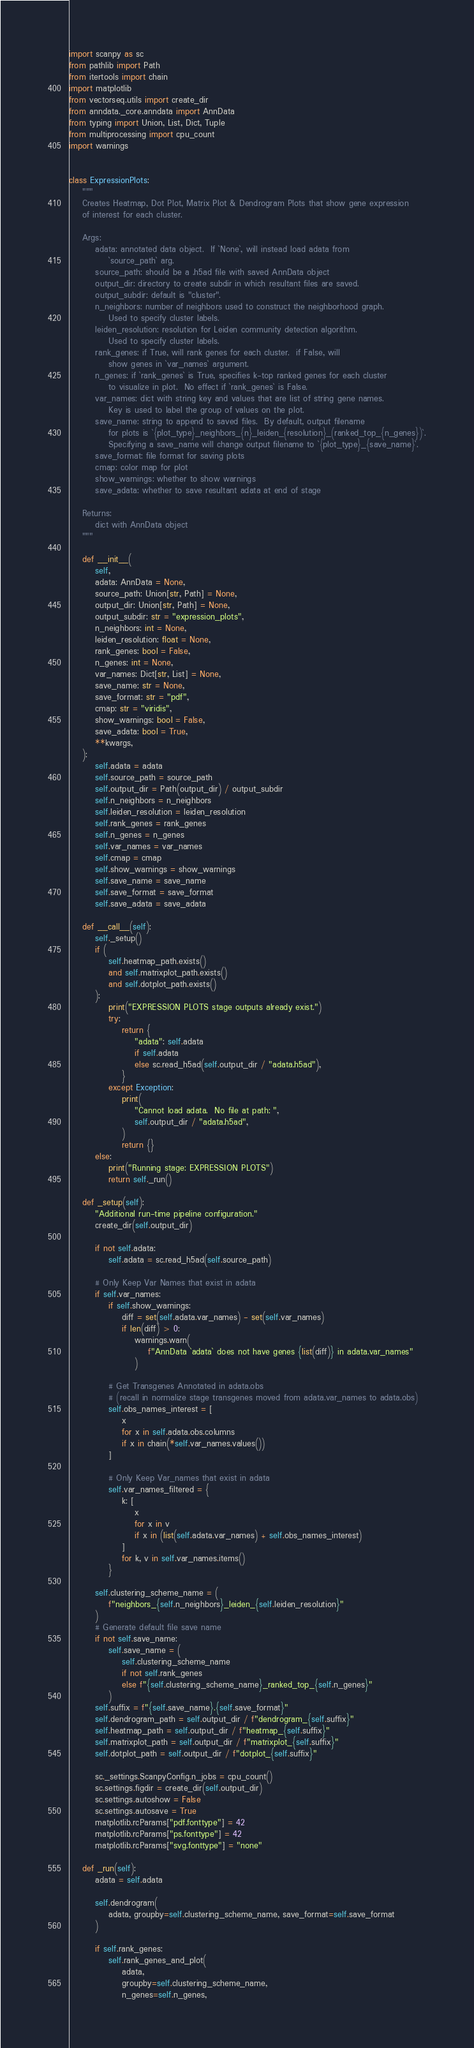Convert code to text. <code><loc_0><loc_0><loc_500><loc_500><_Python_>import scanpy as sc
from pathlib import Path
from itertools import chain
import matplotlib
from vectorseq.utils import create_dir
from anndata._core.anndata import AnnData
from typing import Union, List, Dict, Tuple
from multiprocessing import cpu_count
import warnings


class ExpressionPlots:
    """
    Creates Heatmap, Dot Plot, Matrix Plot & Dendrogram Plots that show gene expression
    of interest for each cluster.

    Args:
        adata: annotated data object.  If `None`, will instead load adata from
            `source_path` arg.
        source_path: should be a .h5ad file with saved AnnData object
        output_dir: directory to create subdir in which resultant files are saved.
        output_subdir: default is "cluster".
        n_neighbors: number of neighbors used to construct the neighborhood graph.
            Used to specify cluster labels.
        leiden_resolution: resolution for Leiden community detection algorithm.
            Used to specify cluster labels.
        rank_genes: if True, will rank genes for each cluster.  if False, will
            show genes in `var_names` argument.
        n_genes: if `rank_genes` is True, specifies k-top ranked genes for each cluster
            to visualize in plot.  No effect if `rank_genes` is False.
        var_names: dict with string key and values that are list of string gene names.
            Key is used to label the group of values on the plot.
        save_name: string to append to saved files.  By default, output filename
            for plots is `{plot_type}_neighbors_{n}_leiden_{resolution}_(ranked_top_{n_genes})`.
            Specifying a save_name will change output filename to `{plot_type}_{save_name}`.
        save_format: file format for saving plots
        cmap: color map for plot
        show_warnings: whether to show warnings
        save_adata: whether to save resultant adata at end of stage

    Returns:
        dict with AnnData object
    """

    def __init__(
        self,
        adata: AnnData = None,
        source_path: Union[str, Path] = None,
        output_dir: Union[str, Path] = None,
        output_subdir: str = "expression_plots",
        n_neighbors: int = None,
        leiden_resolution: float = None,
        rank_genes: bool = False,
        n_genes: int = None,
        var_names: Dict[str, List] = None,
        save_name: str = None,
        save_format: str = "pdf",
        cmap: str = "viridis",
        show_warnings: bool = False,
        save_adata: bool = True,
        **kwargs,
    ):
        self.adata = adata
        self.source_path = source_path
        self.output_dir = Path(output_dir) / output_subdir
        self.n_neighbors = n_neighbors
        self.leiden_resolution = leiden_resolution
        self.rank_genes = rank_genes
        self.n_genes = n_genes
        self.var_names = var_names
        self.cmap = cmap
        self.show_warnings = show_warnings
        self.save_name = save_name
        self.save_format = save_format
        self.save_adata = save_adata

    def __call__(self):
        self._setup()
        if (
            self.heatmap_path.exists()
            and self.matrixplot_path.exists()
            and self.dotplot_path.exists()
        ):
            print("EXPRESSION PLOTS stage outputs already exist.")
            try:
                return {
                    "adata": self.adata
                    if self.adata
                    else sc.read_h5ad(self.output_dir / "adata.h5ad"),
                }
            except Exception:
                print(
                    "Cannot load adata.  No file at path: ",
                    self.output_dir / "adata.h5ad",
                )
                return {}
        else:
            print("Running stage: EXPRESSION PLOTS")
            return self._run()

    def _setup(self):
        "Additional run-time pipeline configuration."
        create_dir(self.output_dir)

        if not self.adata:
            self.adata = sc.read_h5ad(self.source_path)

        # Only Keep Var Names that exist in adata
        if self.var_names:
            if self.show_warnings:
                diff = set(self.adata.var_names) - set(self.var_names)
                if len(diff) > 0:
                    warnings.warn(
                        f"AnnData `adata` does not have genes {list(diff)} in adata.var_names"
                    )

            # Get Transgenes Annotated in adata.obs
            # (recall in normalize stage transgenes moved from adata.var_names to adata.obs)
            self.obs_names_interest = [
                x
                for x in self.adata.obs.columns
                if x in chain(*self.var_names.values())
            ]

            # Only Keep Var_names that exist in adata
            self.var_names_filtered = {
                k: [
                    x
                    for x in v
                    if x in (list(self.adata.var_names) + self.obs_names_interest)
                ]
                for k, v in self.var_names.items()
            }

        self.clustering_scheme_name = (
            f"neighbors_{self.n_neighbors}_leiden_{self.leiden_resolution}"
        )
        # Generate default file save name
        if not self.save_name:
            self.save_name = (
                self.clustering_scheme_name
                if not self.rank_genes
                else f"{self.clustering_scheme_name}_ranked_top_{self.n_genes}"
            )
        self.suffix = f"{self.save_name}.{self.save_format}"
        self.dendrogram_path = self.output_dir / f"dendrogram_{self.suffix}"
        self.heatmap_path = self.output_dir / f"heatmap_{self.suffix}"
        self.matrixplot_path = self.output_dir / f"matrixplot_{self.suffix}"
        self.dotplot_path = self.output_dir / f"dotplot_{self.suffix}"

        sc._settings.ScanpyConfig.n_jobs = cpu_count()
        sc.settings.figdir = create_dir(self.output_dir)
        sc.settings.autoshow = False
        sc.settings.autosave = True
        matplotlib.rcParams["pdf.fonttype"] = 42
        matplotlib.rcParams["ps.fonttype"] = 42
        matplotlib.rcParams["svg.fonttype"] = "none"

    def _run(self):
        adata = self.adata

        self.dendrogram(
            adata, groupby=self.clustering_scheme_name, save_format=self.save_format
        )

        if self.rank_genes:
            self.rank_genes_and_plot(
                adata,
                groupby=self.clustering_scheme_name,
                n_genes=self.n_genes,</code> 